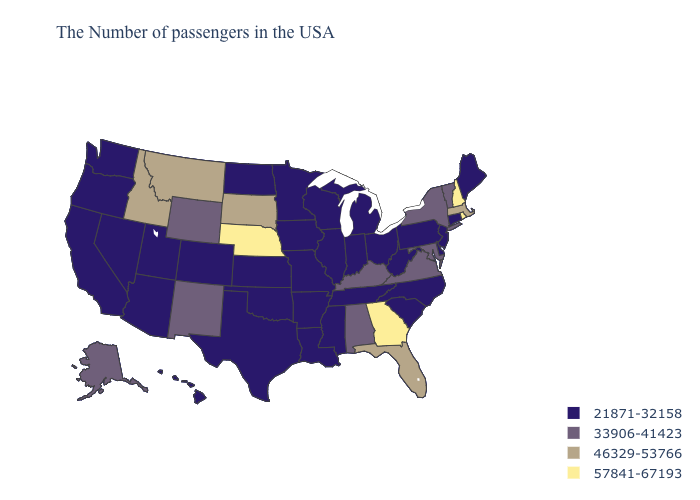What is the highest value in the Northeast ?
Answer briefly. 57841-67193. What is the value of Oregon?
Be succinct. 21871-32158. Does the map have missing data?
Give a very brief answer. No. Among the states that border Alabama , does Georgia have the highest value?
Write a very short answer. Yes. Name the states that have a value in the range 33906-41423?
Concise answer only. Vermont, New York, Maryland, Virginia, Kentucky, Alabama, Wyoming, New Mexico, Alaska. What is the lowest value in the USA?
Quick response, please. 21871-32158. Which states have the highest value in the USA?
Give a very brief answer. Rhode Island, New Hampshire, Georgia, Nebraska. Which states have the lowest value in the USA?
Concise answer only. Maine, Connecticut, New Jersey, Delaware, Pennsylvania, North Carolina, South Carolina, West Virginia, Ohio, Michigan, Indiana, Tennessee, Wisconsin, Illinois, Mississippi, Louisiana, Missouri, Arkansas, Minnesota, Iowa, Kansas, Oklahoma, Texas, North Dakota, Colorado, Utah, Arizona, Nevada, California, Washington, Oregon, Hawaii. Does the first symbol in the legend represent the smallest category?
Concise answer only. Yes. Does Nebraska have the highest value in the MidWest?
Keep it brief. Yes. Does Nebraska have the highest value in the MidWest?
Short answer required. Yes. Does Indiana have the highest value in the USA?
Short answer required. No. Does Idaho have the lowest value in the West?
Give a very brief answer. No. What is the value of Colorado?
Write a very short answer. 21871-32158. What is the lowest value in states that border California?
Short answer required. 21871-32158. 